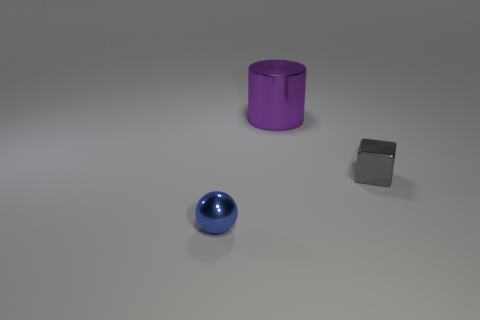Add 3 big metallic objects. How many objects exist? 6 Subtract all cubes. How many objects are left? 2 Subtract 0 cyan spheres. How many objects are left? 3 Subtract all small purple rubber spheres. Subtract all small gray metal objects. How many objects are left? 2 Add 3 large cylinders. How many large cylinders are left? 4 Add 3 tiny blue matte balls. How many tiny blue matte balls exist? 3 